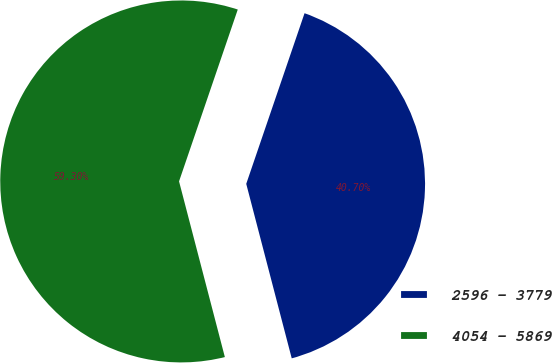Convert chart. <chart><loc_0><loc_0><loc_500><loc_500><pie_chart><fcel>2596 - 3779<fcel>4054 - 5869<nl><fcel>40.7%<fcel>59.3%<nl></chart> 